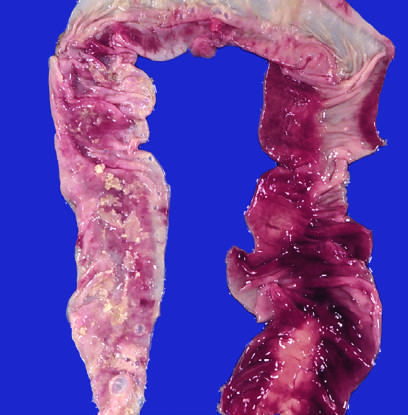does the congested portion of the ileum correspond to areas of hemorrhagic infarction and transmural necrosis?
Answer the question using a single word or phrase. Yes 